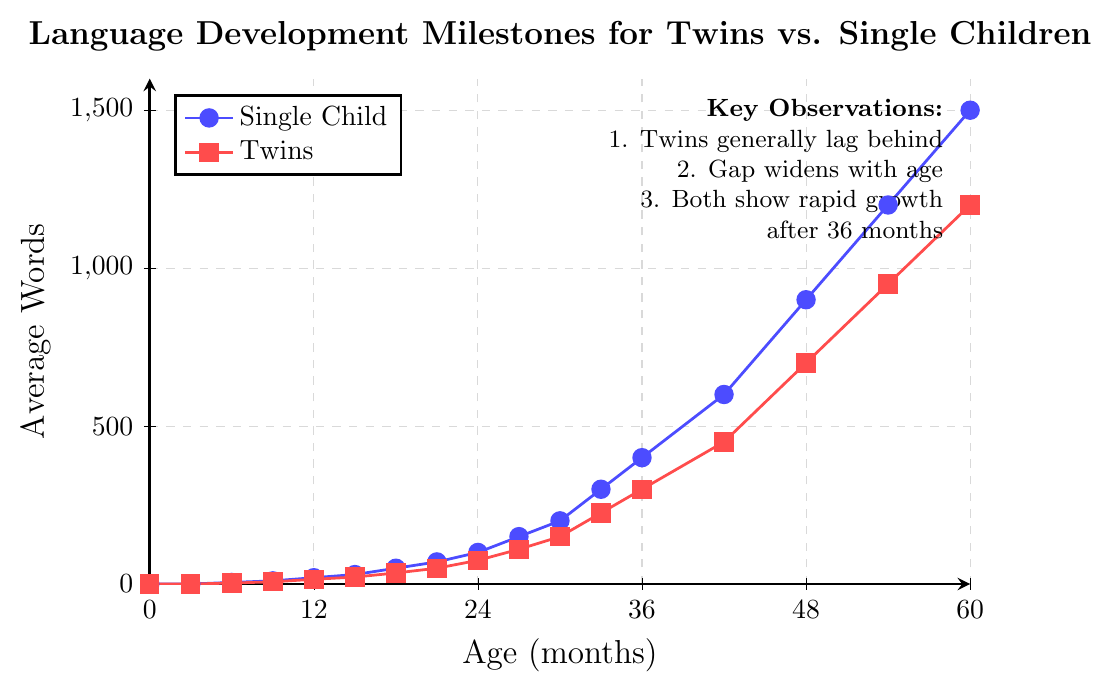At what age do twins and single children both reach an average of 300 words? To find the age at which both groups reach 300 words, check the y-axis values on the plot. The plot shows twins reach this milestone at 36 months, while single children reach it at 33 months.
Answer: Twins: 36 months, Single Children: 33 months How much larger is the average vocabulary of single children compared to twins at 48 months? Look at the y-axis values for both groups at 48 months. Single children have an average of 900 words, while twins have 700. Subtract the smaller value from the larger one: 900 - 700 = 200.
Answer: 200 words Between what ages do twins show the most rapid growth in vocabulary? To find the period of most rapid growth, look for the steepest part of the red line. The steepest increase occurs from 36 to 48 months.
Answer: 36 to 48 months By what percentage is the average vocabulary of single children larger than that of twins at 60 months? At 60 months, single children have an average of 1500 words, and twins have 1200. Calculate the percentage: ((1500 - 1200) / 1200) * 100 = 25%.
Answer: 25% When is the vocabulary of twins exactly half of that of single children? To find when twins' vocabulary is exactly half, look where the value for twins is half of the single children on the y-axis. At 42 months, twins have 450 words and single children have 900 words.
Answer: 42 months Are twins ever ahead of single children in language development according to the figure? Observing the plot from birth to 60 months, the blue line (single children) is always above the red line (twins), indicating twins are consistently behind.
Answer: No At 30 months, what is the difference in the vocabulary of twins and single children? Check the y-axis values at 30 months. Single children are at 200 words, and twins are at 150 words. The difference is 200 - 150 = 50.
Answer: 50 words How many words do single children know at 18 months compared to twins at 24 months? At 18 months, single children know 50 words. At 24 months, twins know 75 words. Compare the two values: 50 vs 75.
Answer: Single children: 50 words, Twins: 75 words From 36 to 48 months, how many more words do single children learn compared to twins? For single children from 36 to 48 months: 900 - 400 = 500 words. For twins: 700 - 300 = 400 words. Difference: 500 - 400 = 100.
Answer: 100 words 